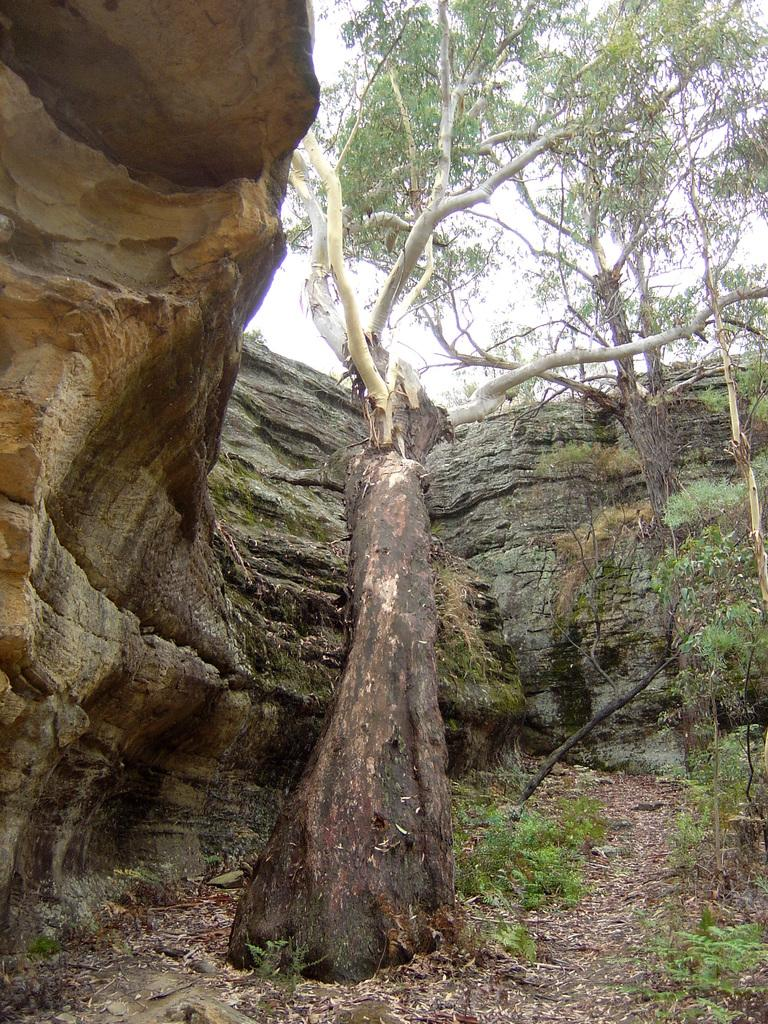What type of vegetation can be seen in the image? There are trees and plants in the image. What structure is visible in the image? There is a wall in the image. What type of copper object can be seen in the image? There is no copper object present in the image. How many needles are visible in the image? There are no needles present in the image. 